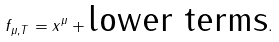Convert formula to latex. <formula><loc_0><loc_0><loc_500><loc_500>f _ { \mu , T } = x ^ { \mu } + \text {lower terms} .</formula> 